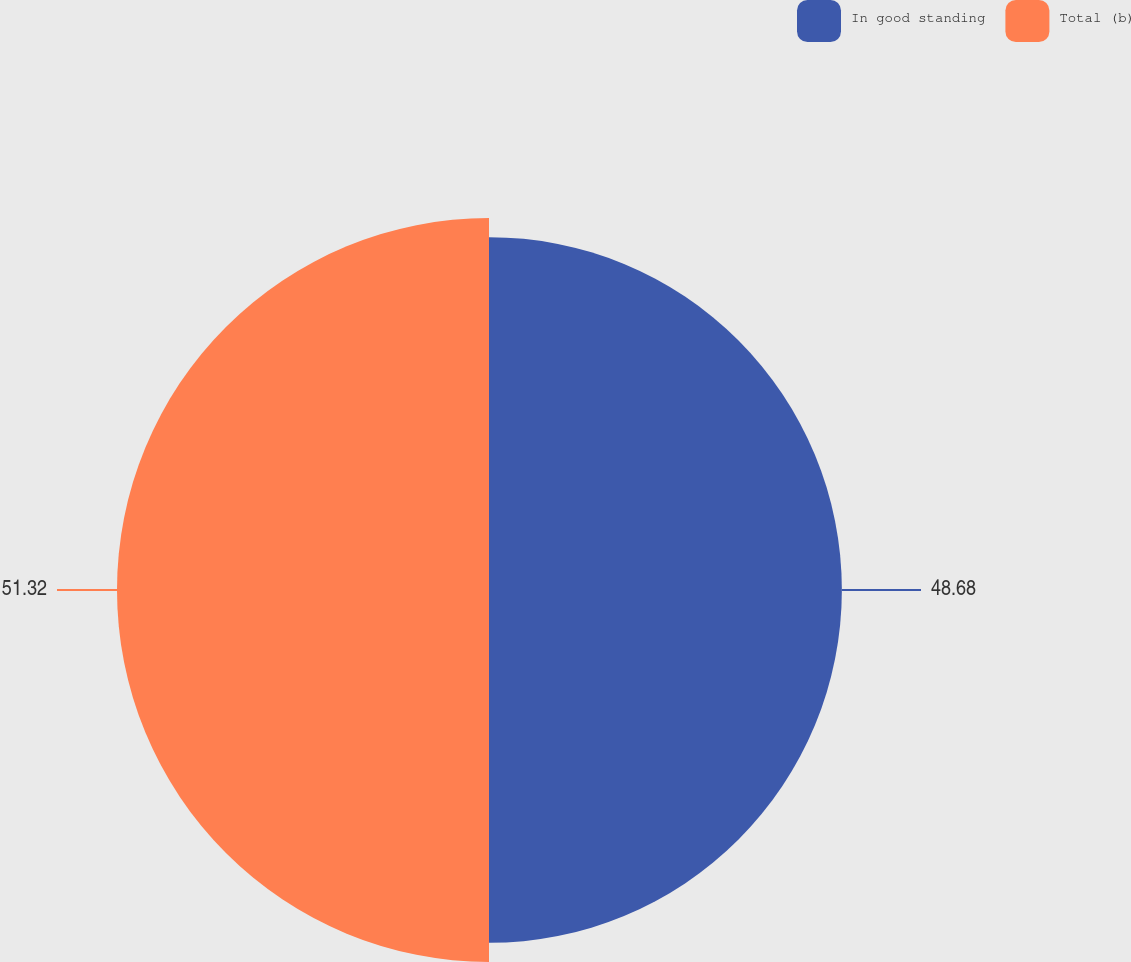Convert chart. <chart><loc_0><loc_0><loc_500><loc_500><pie_chart><fcel>In good standing<fcel>Total (b)<nl><fcel>48.68%<fcel>51.32%<nl></chart> 